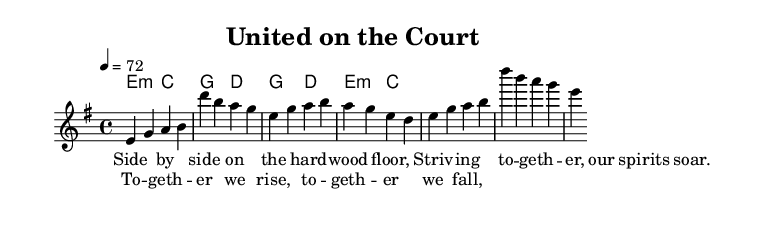What is the key signature of this music? The key signature is E minor, which is indicated by one sharp (F#). The 'e' at the beginning of the global block denotes that E minor is the key being used throughout the piece.
Answer: E minor What is the time signature of this music? The time signature is 4/4, which is indicated at the beginning of the global block. This means there are four beats in each measure, and the quarter note gets one beat.
Answer: 4/4 What is the tempo marking in this music? The tempo marking is indicated as 4 = 72, meaning that the quarter note is set to 72 beats per minute. This suggests a moderate walking pace in the tempo of the piece.
Answer: 72 How many measures are in the verse section? The verse section contains 4 measures. This can be determined by counting the melody notes provided under the verse section which are grouped into 4 sets.
Answer: 4 What chord follows the E minor in the verse? The chord that follows E minor is C major, as shown in the harmonies portion of the score where the first chord is E minor, followed by C major.
Answer: C major What lyrical theme is expressed in the chorus? The lyrical theme expressed in the chorus is teamwork, as indicated by the lyrics "Together we rise, together we fall." This reflects the unity and collaboration that is essential in both sports and friendships.
Answer: Teamwork What is the relationship between the verse and the chorus in terms of music structure? The relationship is that the verse provides the setup with a narrative about striving together, while the chorus emphasizes collective unity, aligning with common song structures in ballads where verses tell a story and choruses drive the main message.
Answer: Narrative and unity 